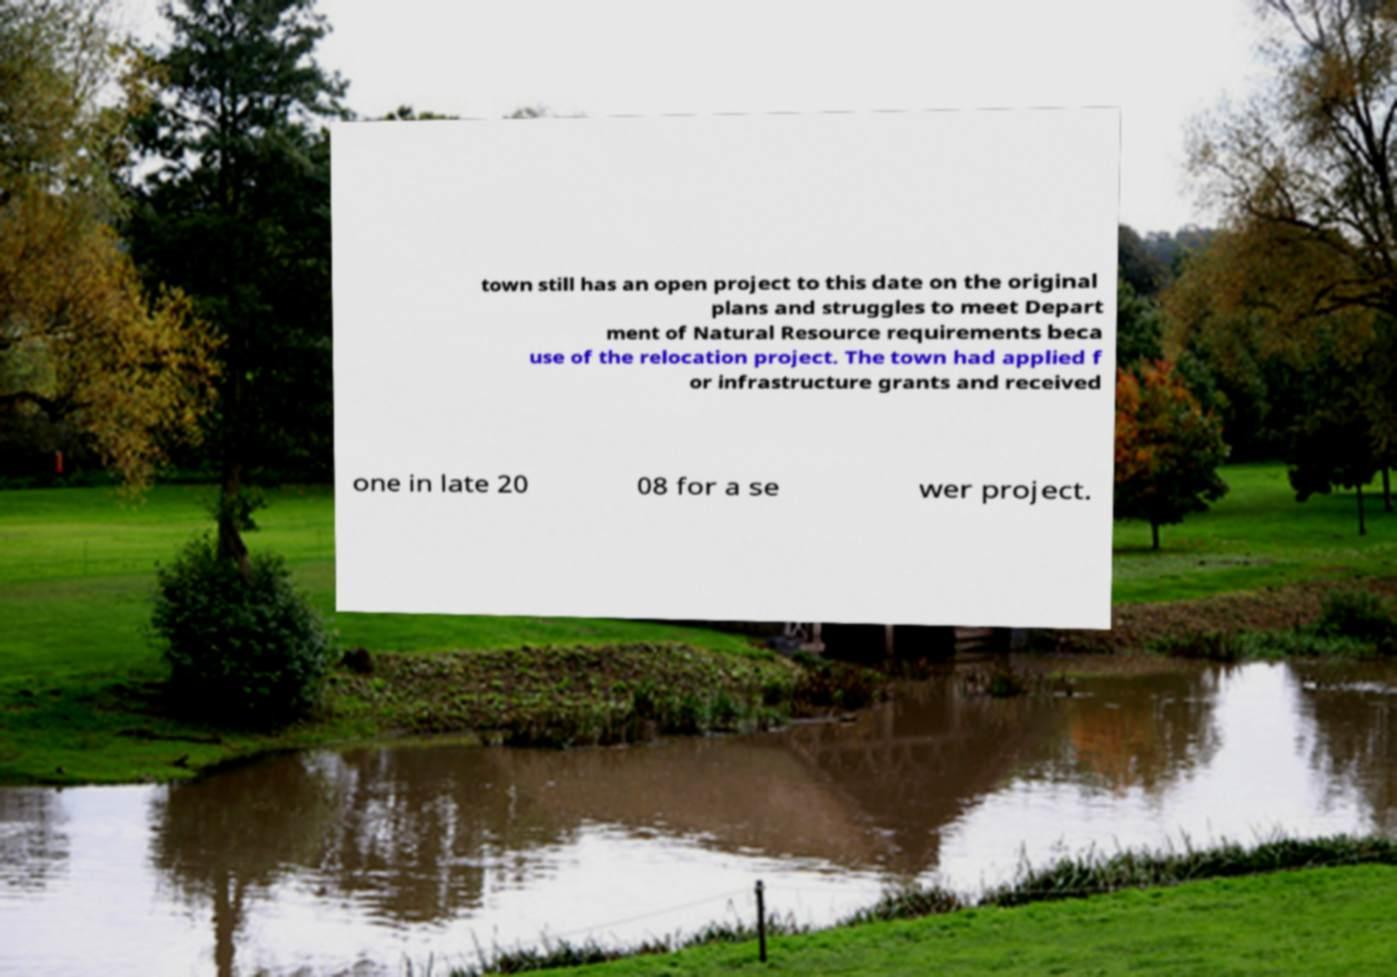What messages or text are displayed in this image? I need them in a readable, typed format. town still has an open project to this date on the original plans and struggles to meet Depart ment of Natural Resource requirements beca use of the relocation project. The town had applied f or infrastructure grants and received one in late 20 08 for a se wer project. 